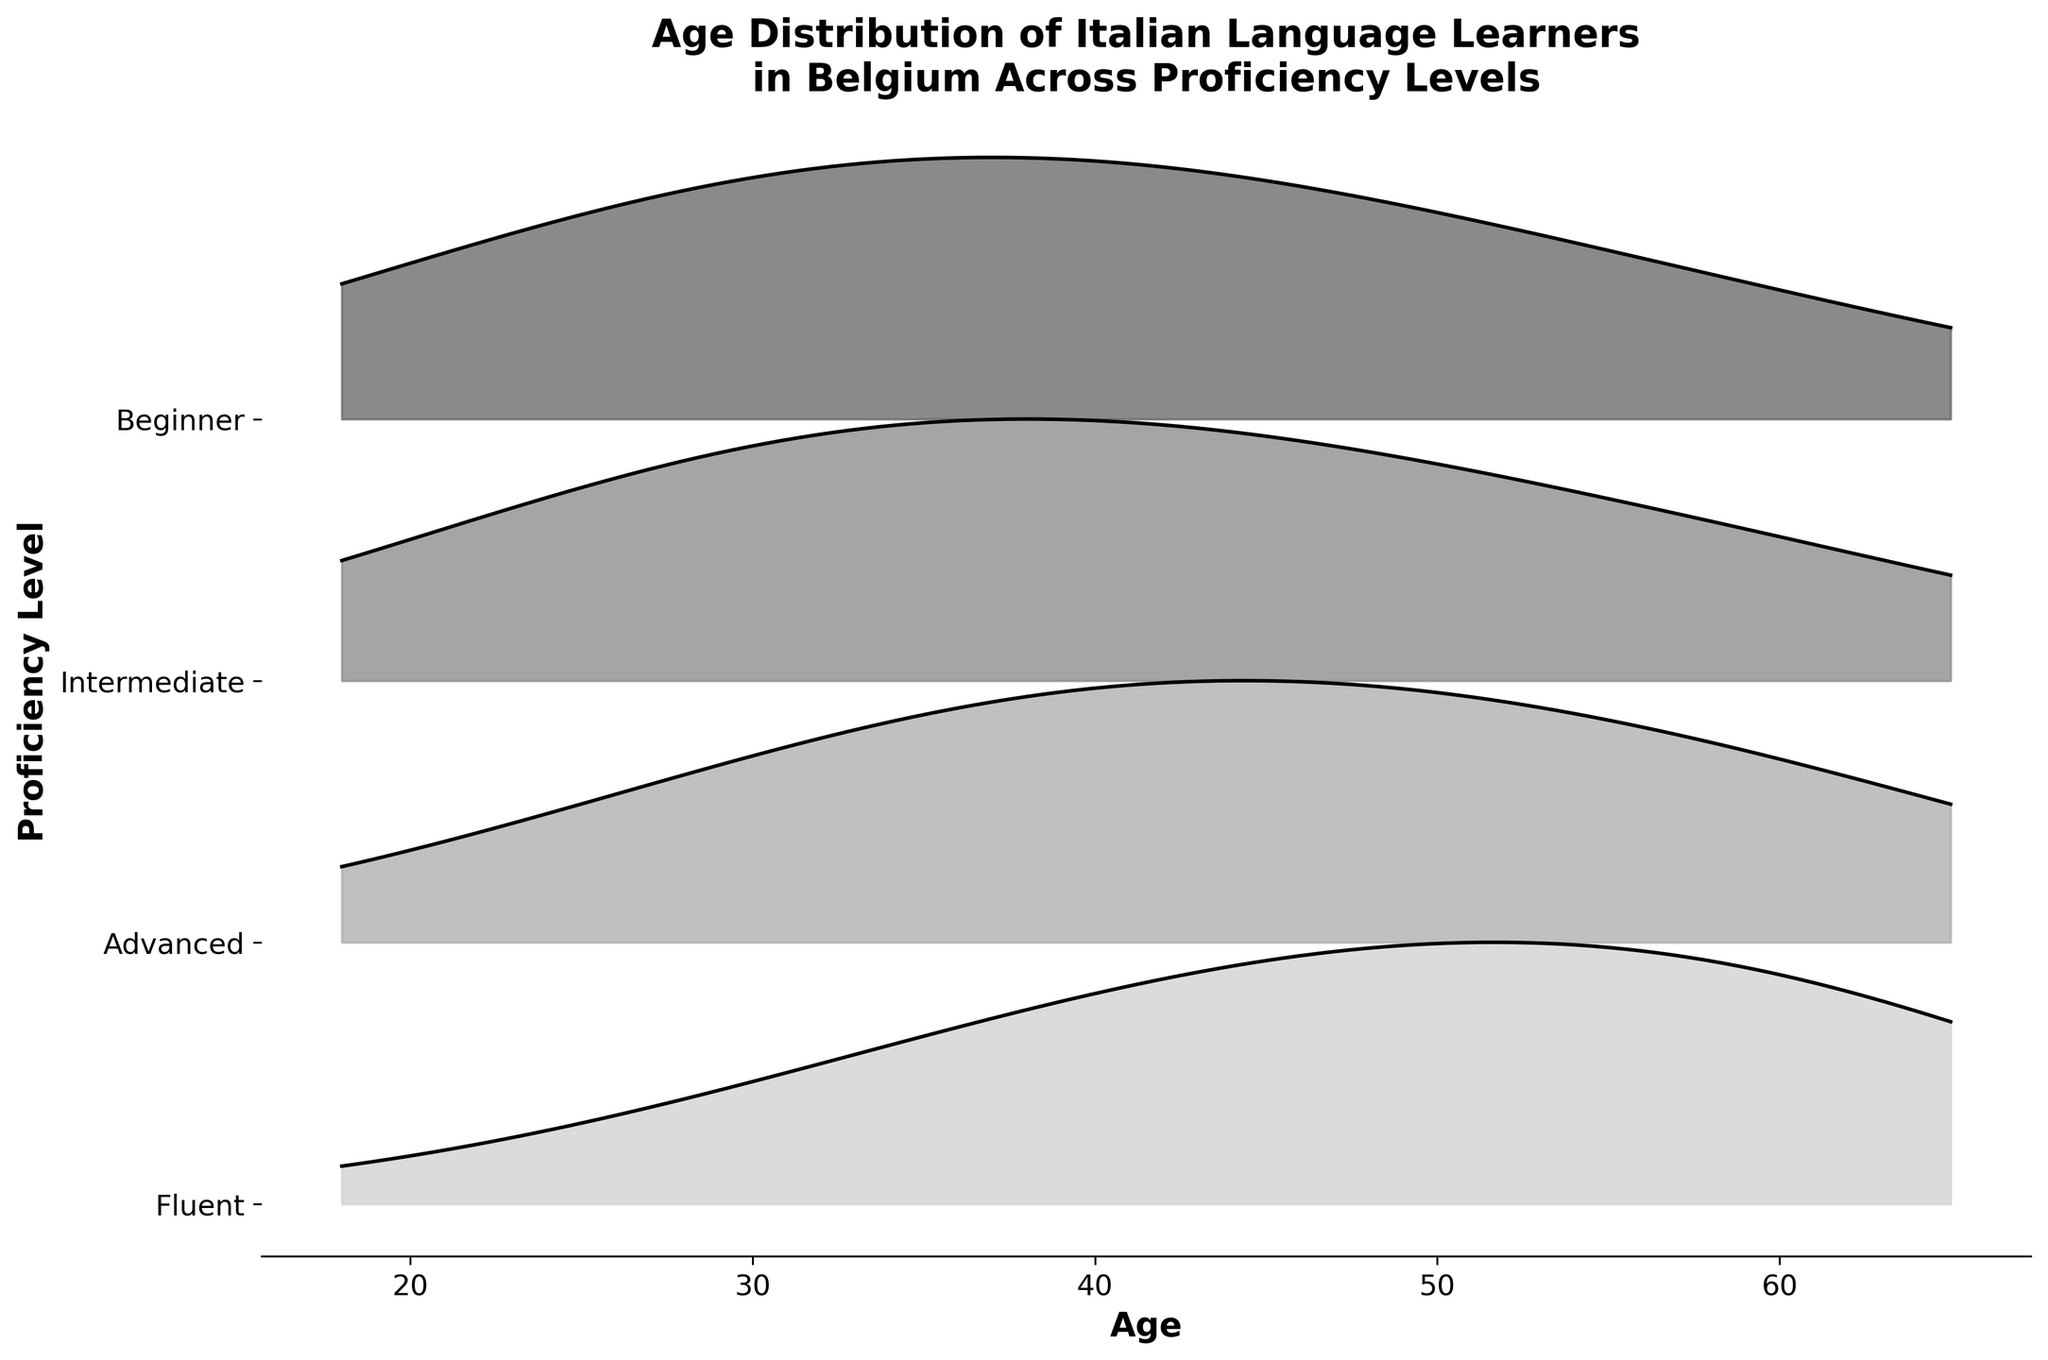What is the title of the plot? The title of the plot is usually placed at the top of the figure. In this case, it says "Age Distribution of Italian Language Learners in Belgium Across Proficiency Levels"
Answer: Age Distribution of Italian Language Learners in Belgium Across Proficiency Levels Which proficiency level shows the highest density among people aged 45? By examining the plot around the age of 45, we can observe that the density peak is the highest for the Advanced proficiency level.
Answer: Advanced How does the density of age 25 compare between Beginner and Fluent learners? Comparing the heights of the density curves at age 25 for both Beginner and Fluent learners, Beginner has a higher density than Fluent.
Answer: Beginner At what age do Intermediate learners show the highest density? We look at the highest point in the Intermediate ridge, which occurs around age 35.
Answer: 35 Which proficiency level's ridgeline is the most spread out across different ages? The Fluent proficiency level has a ridgeline that appears to spread more evenly across ages from 18 to 65.
Answer: Fluent What is the general trend of density for Advanced proficiency learners as age increases? Observing the ridgeline for Advanced proficiency learners, the density shows an increasing trend up to about age 45 and then gradually decreases.
Answer: Increases then decreases Between which two age groups does the density of Fluent learners peak? The highest peak for Fluent learners can be seen between the ages of 55 and 65.
Answer: 55 and 65 Is the density higher for Intermediate or Advanced learners aged 35? Comparing the density at age 35 for both Intermediate and Advanced proficiency levels, Intermediate learners have a slightly higher density.
Answer: Intermediate What is the shape of the ridgeline for Beginner learners? The ridgeline for Beginner learners starts low, increases to a peak around age 35, and then gradually decreases, forming a bell shape.
Answer: Bell shape How does the density vary for Beginner learners around ages 18 and 65? For Beginner learners, the density is lower at both age 18 and age 65, showing a similar value of approximately 0.02 at both ends.
Answer: Similar and low 